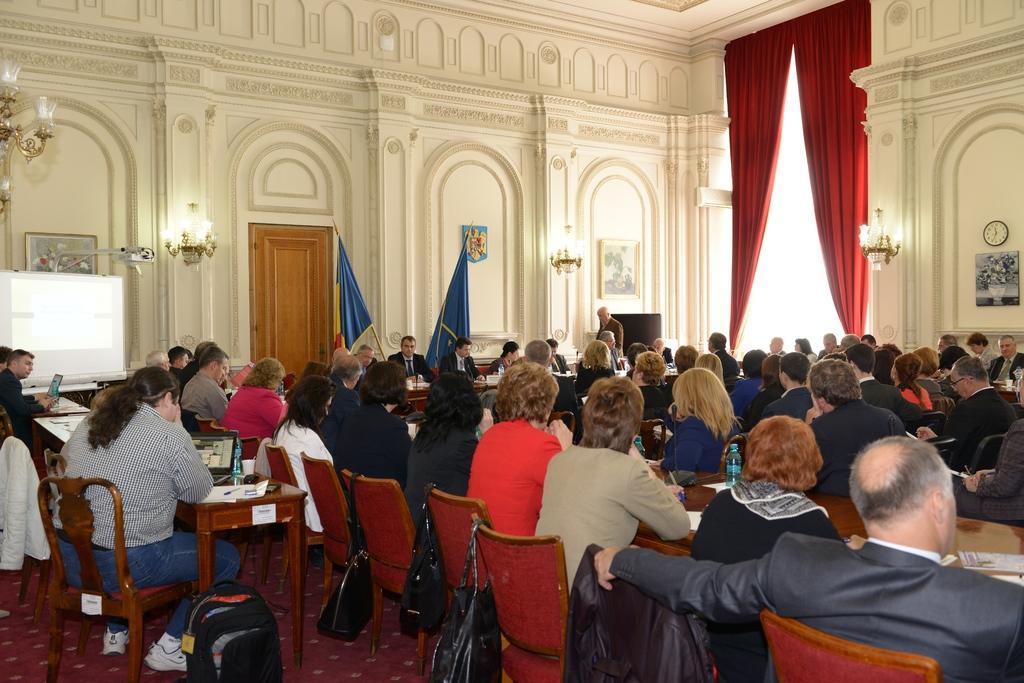How would you summarize this image in a sentence or two? It looks like a conference room , there are lot of people sitting and in the front there is another table in front of that there are some other people sitting , back side there are two blue color flags in the background there is a big red color curtain and a cream color wall. 